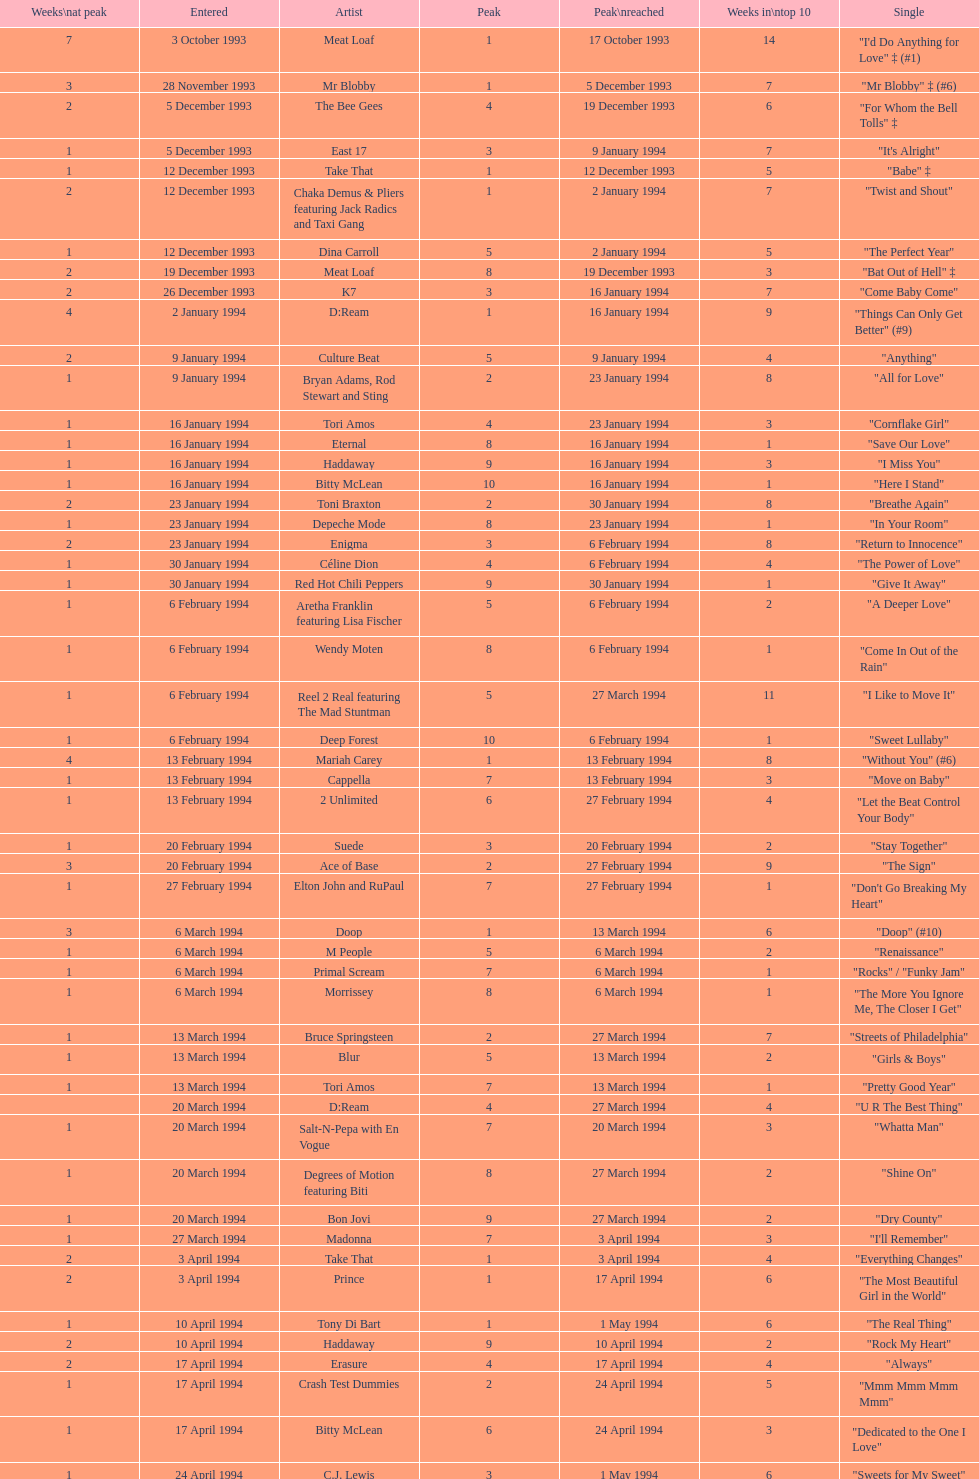Which artist only has its single entered on 2 january 1994? D:Ream. 